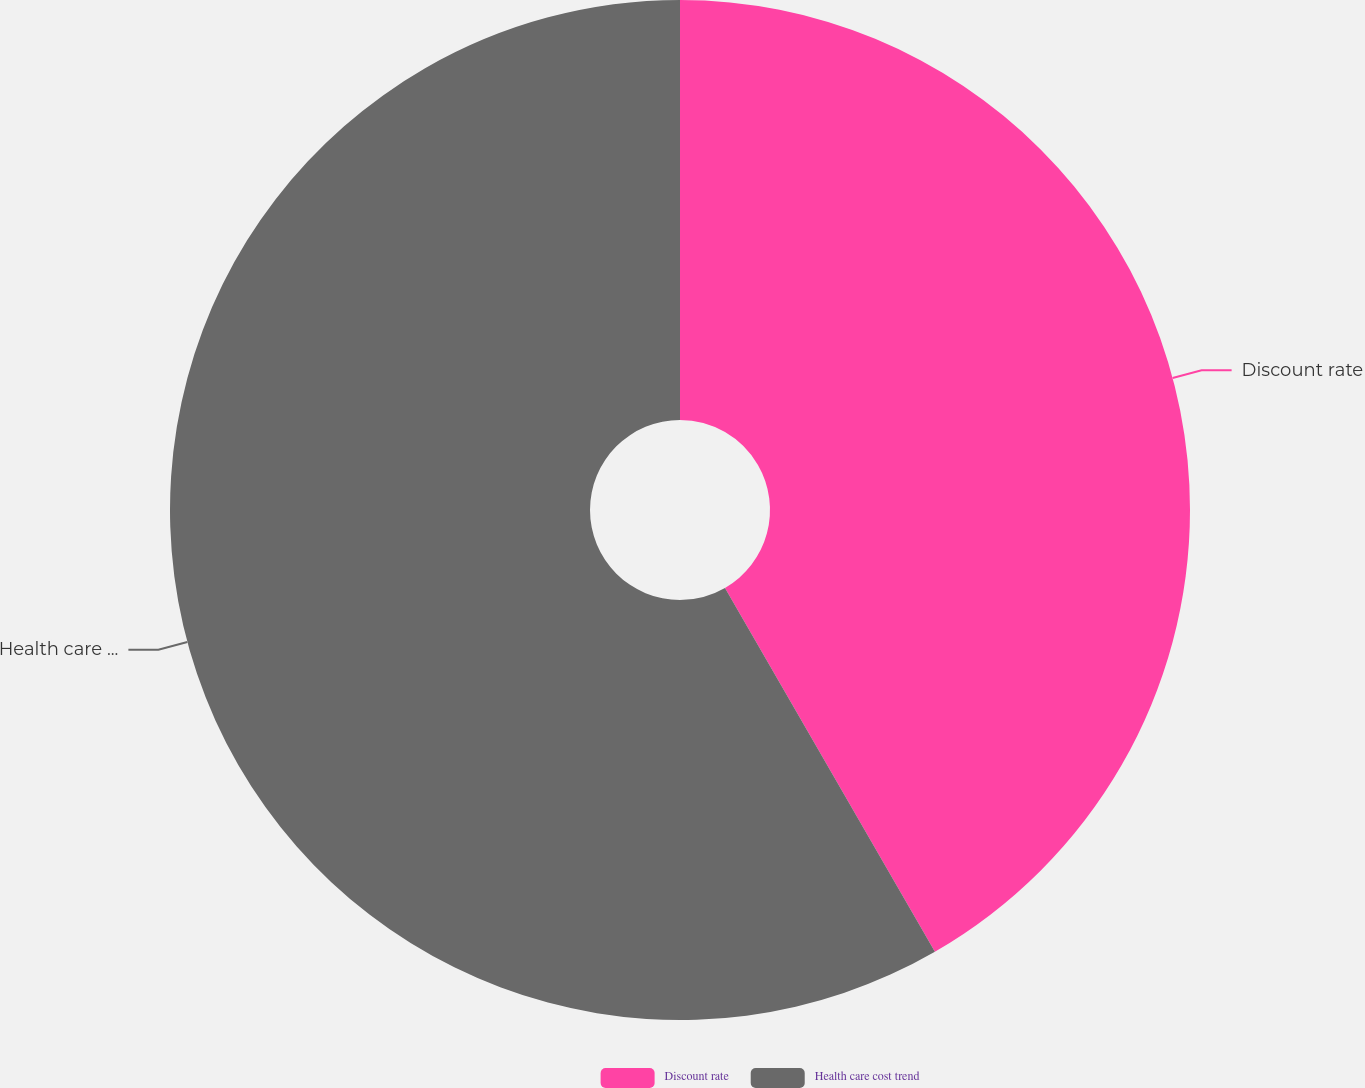<chart> <loc_0><loc_0><loc_500><loc_500><pie_chart><fcel>Discount rate<fcel>Health care cost trend<nl><fcel>41.67%<fcel>58.33%<nl></chart> 